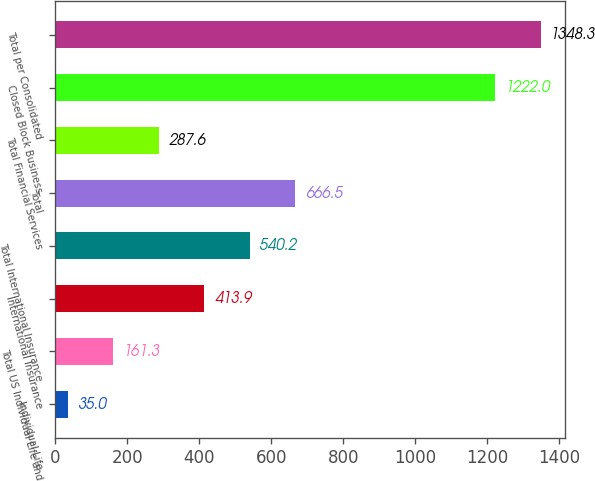<chart> <loc_0><loc_0><loc_500><loc_500><bar_chart><fcel>Individual Life<fcel>Total US Individual Life and<fcel>International Insurance<fcel>Total International Insurance<fcel>Total<fcel>Total Financial Services<fcel>Closed Block Business<fcel>Total per Consolidated<nl><fcel>35<fcel>161.3<fcel>413.9<fcel>540.2<fcel>666.5<fcel>287.6<fcel>1222<fcel>1348.3<nl></chart> 